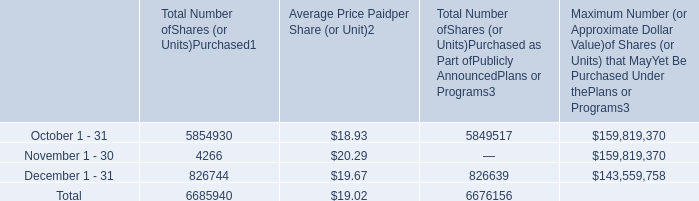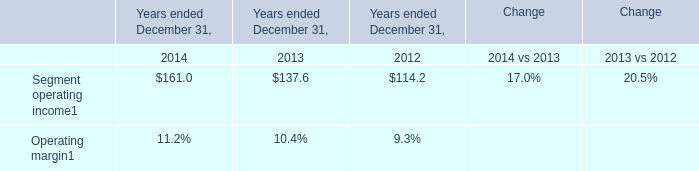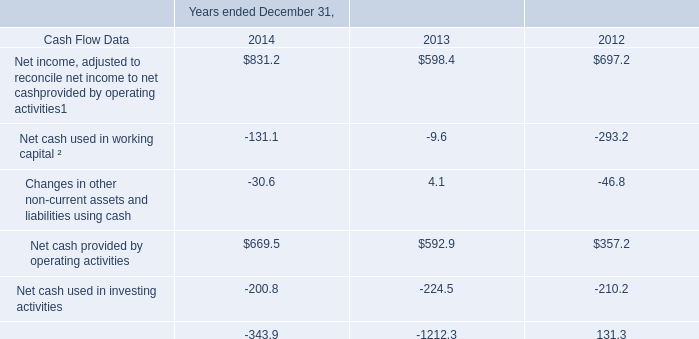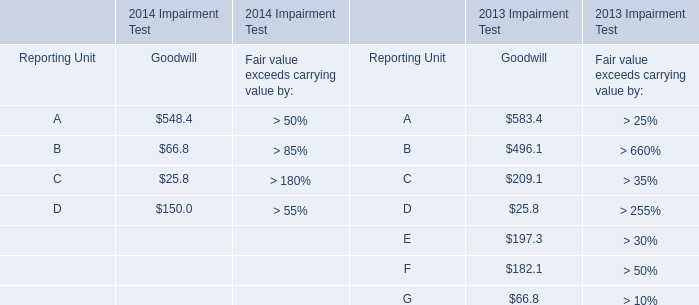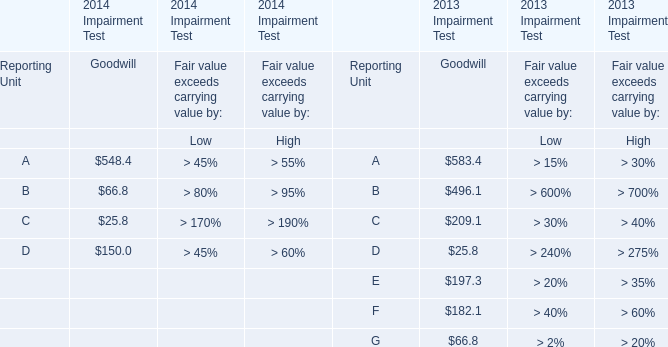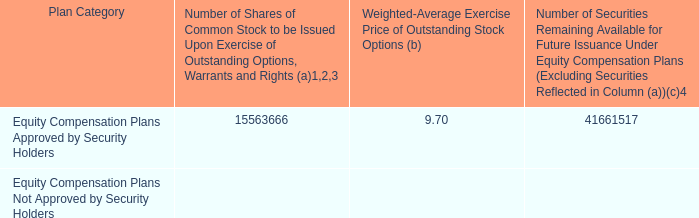how many combined shares are available under the 2014 incentive plan , the 2009 incentive plan and the 2006 employee stock purchase plan combined? 
Computations: ((29045044 + 12181214) + 435259)
Answer: 41661517.0. 